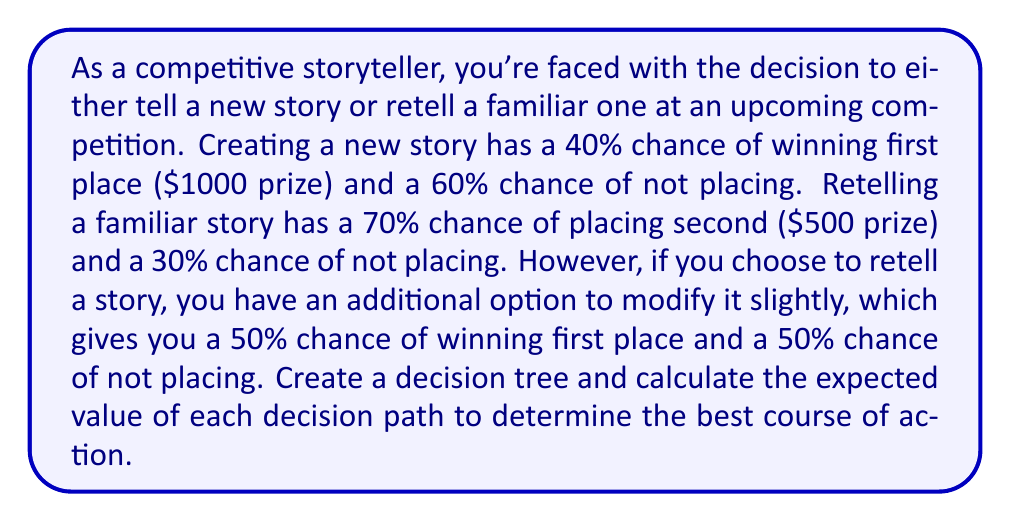Could you help me with this problem? Let's create a decision tree and calculate the expected value for each path:

1. New Story:
   - 40% chance of winning $1000
   - 60% chance of winning $0
   Expected Value: $EV_{new} = 0.40 \times 1000 + 0.60 \times 0 = 400$

2. Retell Familiar Story:
   - 70% chance of winning $500
   - 30% chance of winning $0
   Expected Value: $EV_{retell} = 0.70 \times 500 + 0.30 \times 0 = 350$

3. Modify Familiar Story:
   - 50% chance of winning $1000
   - 50% chance of winning $0
   Expected Value: $EV_{modify} = 0.50 \times 1000 + 0.50 \times 0 = 500$

The decision tree can be represented as follows:

[asy]
import geometry;

pair A = (0,0);
pair B1 = (100,50);
pair B2 = (100,-50);
pair C1 = (200,100);
pair C2 = (200,0);
pair C3 = (200,-100);

draw(A--B1--C1);
draw(A--B1--C2);
draw(A--B2--C3);

label("Start", A, W);
label("New Story", B1, N);
label("Retell", B2, S);
label("Win ($1000)", C1, E);
label("Lose ($0)", C2, E);
label("2nd Place ($500)", C3, E);

label("40%", (A+B1)/2, N);
label("60%", (B1+C2)/2, N);
label("70%", (B2+C3)/2, S);
label("30%", (B2+A)/2, S);

dot(A);
dot(B1);
dot(B2);
dot(C1);
dot(C2);
dot(C3);
[/asy]

To determine the best course of action, we compare the expected values:

1. New Story: $400
2. Retell Familiar Story: $350
3. Modify Familiar Story: $500

The highest expected value is $500, which corresponds to modifying a familiar story.
Answer: The best decision is to modify a familiar story, with an expected value of $500. 